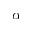<formula> <loc_0><loc_0><loc_500><loc_500>\alpha</formula> 